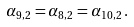Convert formula to latex. <formula><loc_0><loc_0><loc_500><loc_500>\alpha _ { 9 , 2 } = \alpha _ { 8 , 2 } = \alpha _ { 1 0 , 2 } \, .</formula> 